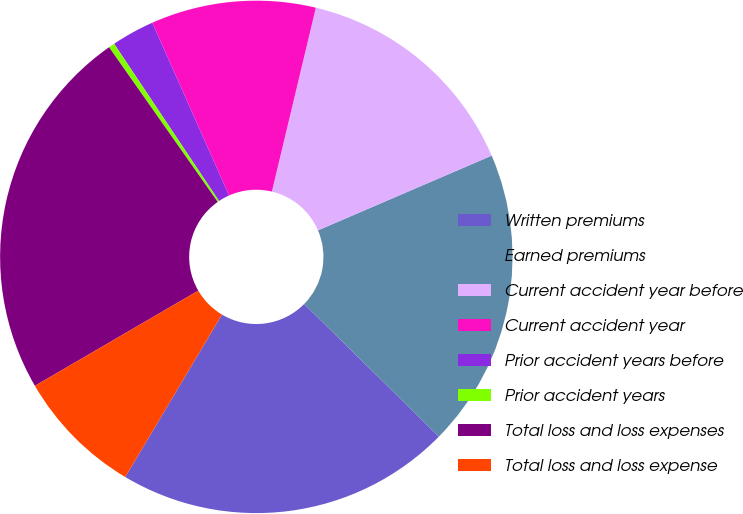Convert chart to OTSL. <chart><loc_0><loc_0><loc_500><loc_500><pie_chart><fcel>Written premiums<fcel>Earned premiums<fcel>Current accident year before<fcel>Current accident year<fcel>Prior accident years before<fcel>Prior accident years<fcel>Total loss and loss expenses<fcel>Total loss and loss expense<nl><fcel>21.17%<fcel>18.84%<fcel>14.8%<fcel>10.39%<fcel>2.71%<fcel>0.38%<fcel>23.65%<fcel>8.06%<nl></chart> 